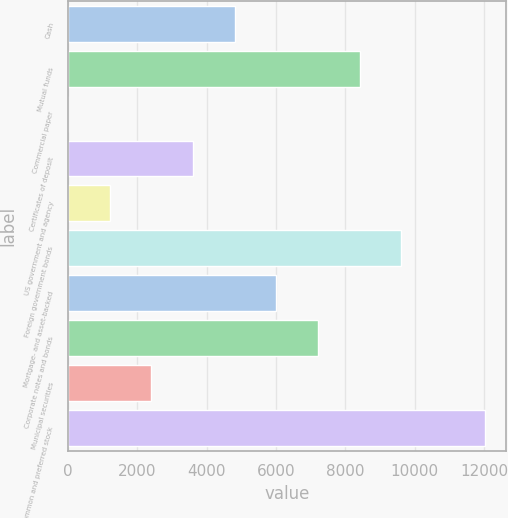Convert chart. <chart><loc_0><loc_0><loc_500><loc_500><bar_chart><fcel>Cash<fcel>Mutual funds<fcel>Commercial paper<fcel>Certificates of deposit<fcel>US government and agency<fcel>Foreign government bonds<fcel>Mortgage- and asset-backed<fcel>Corporate notes and bonds<fcel>Municipal securities<fcel>Common and preferred stock<nl><fcel>4811.71<fcel>8419.84<fcel>0.87<fcel>3609<fcel>1203.58<fcel>9622.55<fcel>6014.42<fcel>7217.13<fcel>2406.29<fcel>12028<nl></chart> 